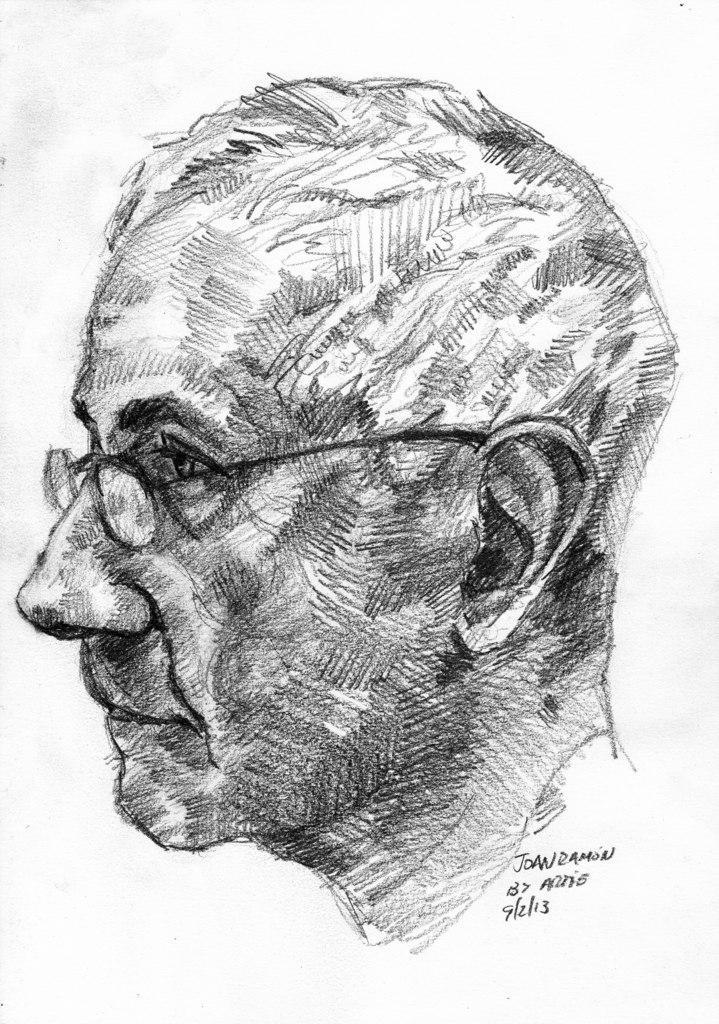Can you describe this image briefly? In this picture we can see an art on the paper. 